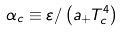Convert formula to latex. <formula><loc_0><loc_0><loc_500><loc_500>\alpha _ { c } \equiv \varepsilon / \left ( a _ { + } T _ { c } ^ { 4 } \right )</formula> 